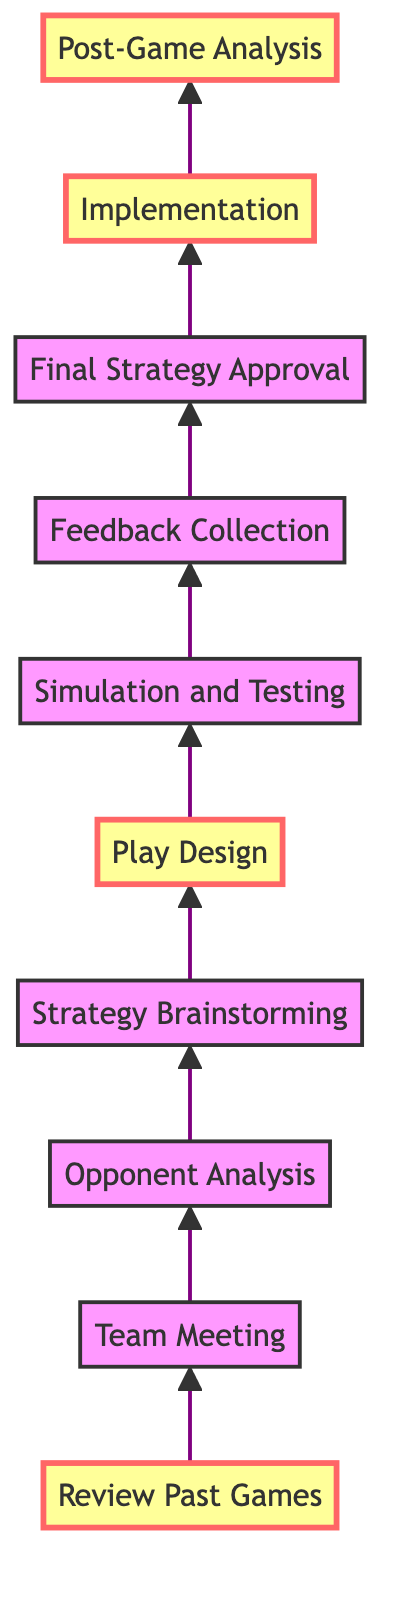What is the first step in the strategy development process? The first step is "Review Past Games." This step is at the bottom of the flow chart, indicating it is the starting point for the entire strategy development process.
Answer: Review Past Games Which step comes after "Team Meeting"? The step that comes after "Team Meeting" is "Opponent Analysis." By following the flow arrows from "Team Meeting," you can see that it directly leads to "Opponent Analysis."
Answer: Opponent Analysis How many steps are there in total in the diagram? There are ten steps in total, as counted from the bottom to the top of the flow chart, with each node representing a specific stage in the process.
Answer: Ten What is the last action in the flow chart? The last action in the flow chart is "Post-Game Analysis." It is located at the top of the flow chart, indicating it is the final step after all previous actions are completed.
Answer: Post-Game Analysis Which two steps are marked as important? The two steps marked as important are "Review Past Games" and "Play Design." The diagram highlights these steps with special markings that differentiate them from others.
Answer: Review Past Games, Play Design What is the relationship between "Simulation and Testing" and "Feedback Collection"? The relationship is that "Simulation and Testing" must be completed before "Feedback Collection" can occur. In the flow, the arrow indicates that the output from one step leads directly to the subsequent step.
Answer: "Simulation and Testing" leads to "Feedback Collection" How does "Implementation" relate to "Final Strategy Approval"? "Implementation" follows "Final Strategy Approval," meaning that final approval of the strategy must happen before it can be executed in upcoming games. The flow indicates a direct flow from one to the other.
Answer: "Implementation" follows "Final Strategy Approval" What is the primary focus of the "Team Meeting"? The primary focus of the "Team Meeting" is to discuss observations from past games and set objectives. This is inferred from the description associated with that step in the diagram.
Answer: Discuss observations and set objectives What role does "Opponent Analysis" play in the strategy process? "Opponent Analysis" is crucial because it allows the team to understand their opponent's playing style and identify areas that can be exploited in developing the strategy. This is the key detail stated in the description of that step.
Answer: Understand opponent's style and exploit weaknesses What is the main goal of "Post-Game Analysis"? The main goal of "Post-Game Analysis" is to evaluate the performance of the new strategy and identify lessons learned for future improvements. This is explicitly defined in the step's description in the diagram.
Answer: Evaluate performance and identify lessons learned 